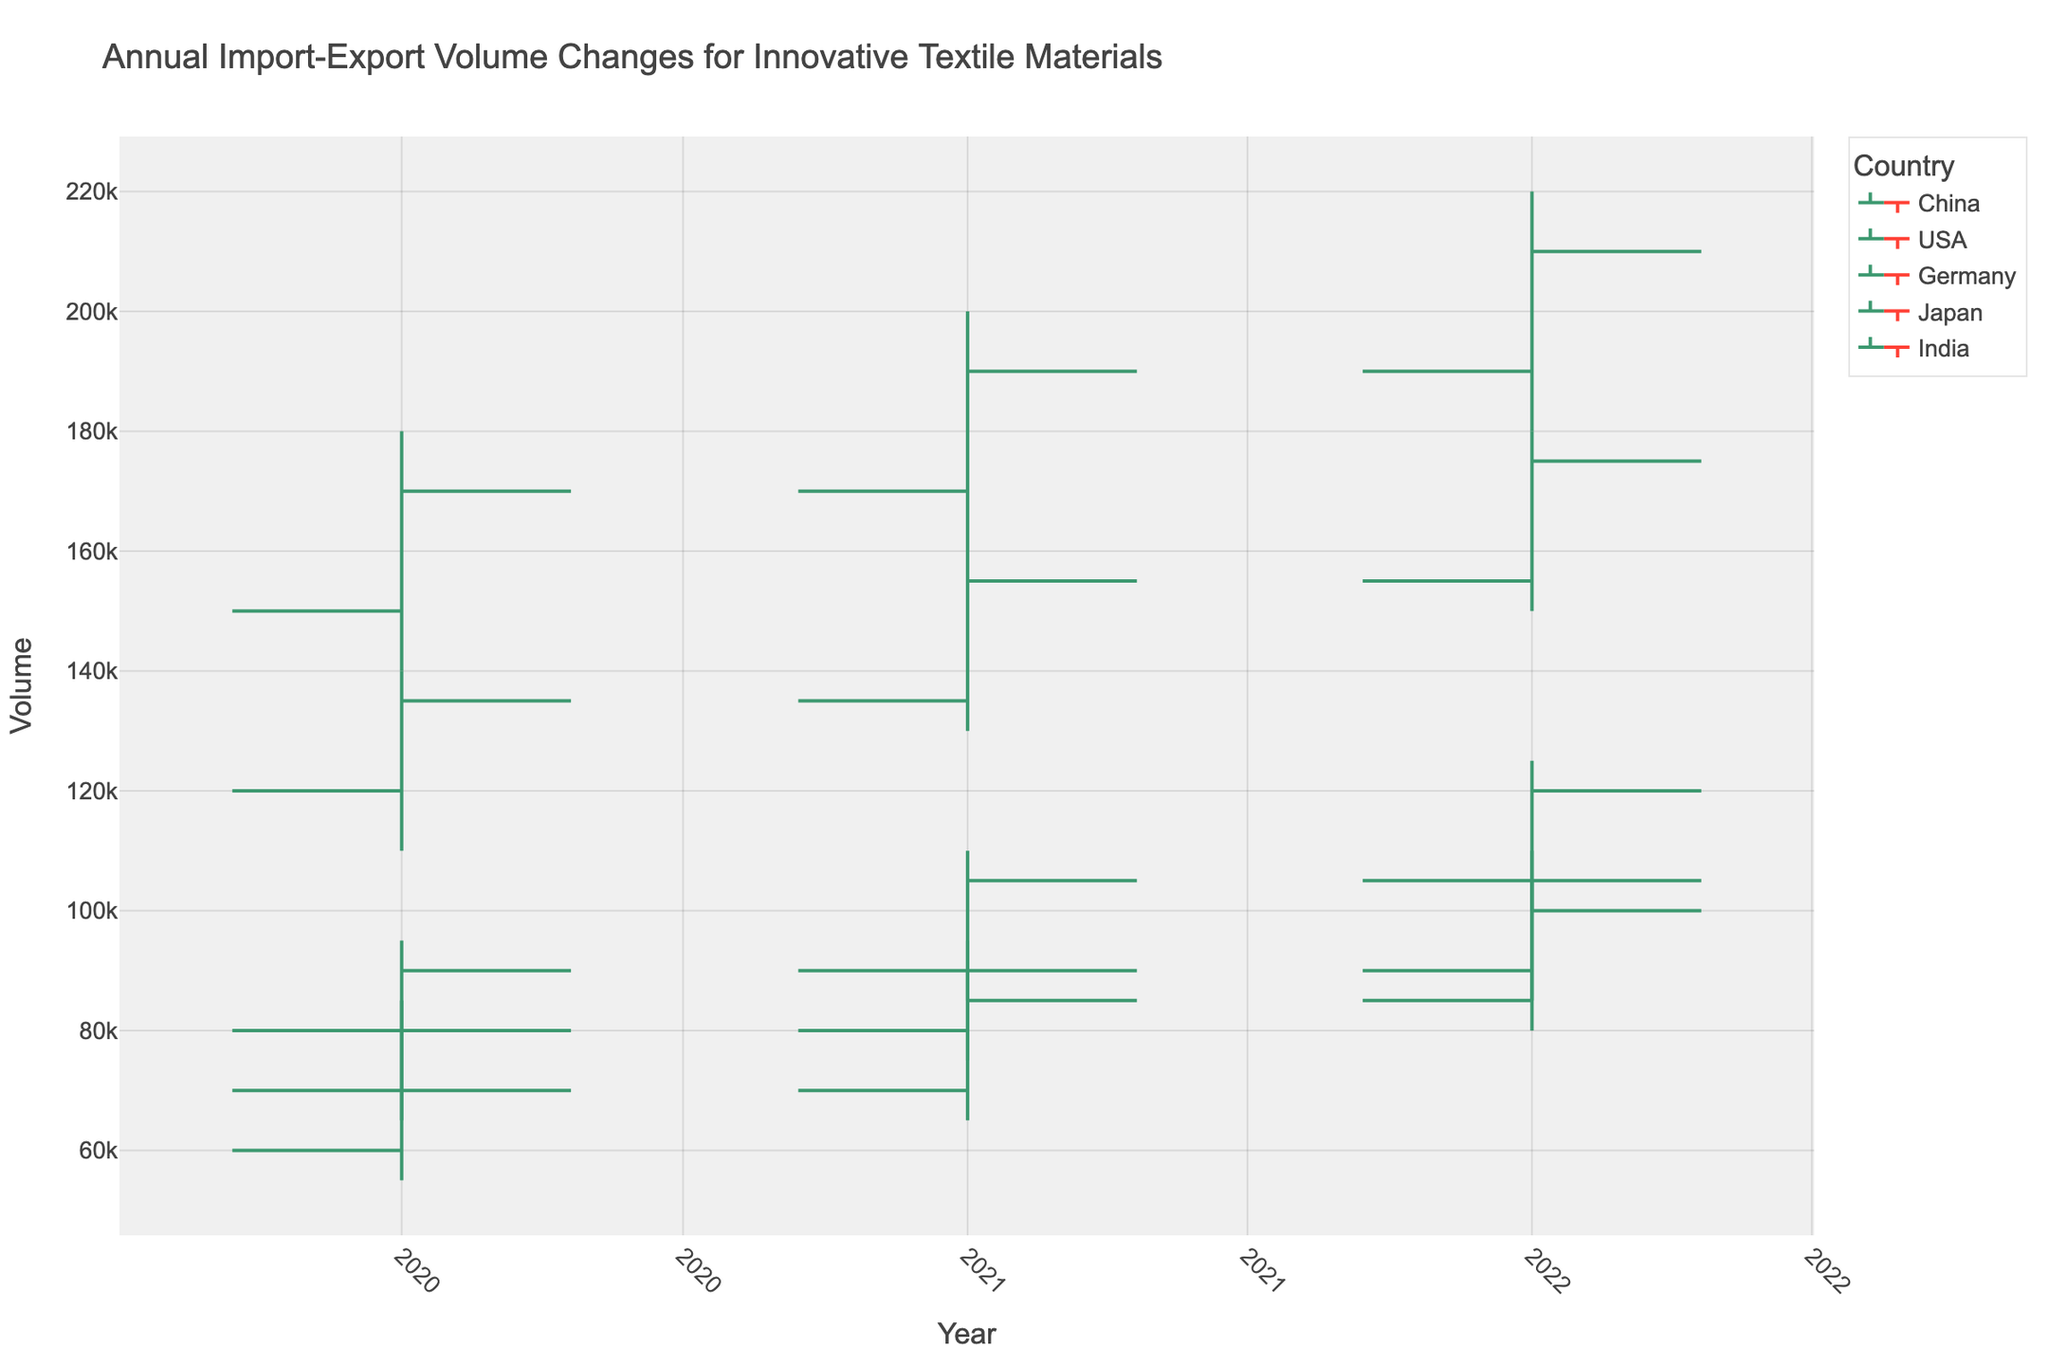Which country had the highest import-export volume in 2020? The highest import-export volume in 2020 is indicated by the highest "High" value in the OHLC chart. For 2020, China had the highest volume with a peak at 180,000.
Answer: China What was the lowest import-export volume for India in 2021? The lowest import-export volume for India in 2021 is represented by the "Low" value. According to the chart, the lowest value for India in 2021 was 65,000.
Answer: 65,000 How did the closing volume of USA change from 2020 to 2022? To determine this, look at the "Close" values for USA in 2020, 2021, and 2022. In 2020, it was 135,000; in 2021, 155,000; and in 2022, 175,000. So it increased each year.
Answer: Increased Which country had the smallest range of import-export volumes in 2022, and what was the range? The range can be calculated by subtracting the "Low" value from the "High" value for each country in 2022. Germany had the smallest range: 125,000 - 100,000 = 25,000.
Answer: Germany, 25,000 What is the average closing volume for Japan across all the years presented? The closing volumes for Japan are 80,000 (2020), 90,000 (2021), and 105,000 (2022). The average is (80,000 + 90,000 + 105,000) / 3.
Answer: 91,667 Compare the import-export trend for China and Germany from 2020 to 2022. Looking at the "Close" values for both countries, China's volumes went from 170,000 to 190,000 to 210,000, showing a consistent rise. Germany's volumes went from 90,000 to 105,000 to 120,000, also showing a rise but with lower values.
Answer: Both increased, China at higher volumes What was the highest recorded import-export volume overall between 2020 and 2022? The highest volume overall is indicated by the maximum "High" value in the data set. That value is 220,000 for China in 2022.
Answer: 220,000 Between USA and India, which country had a higher average “Low” value across the three years? Calculate the average "Low" values for USA (110,000, 130,000, 150,000) and India (55,000, 65,000, 80,000). For USA: (110,000 + 130,000 + 150,000) / 3 = 130,000. For India: (55,000 + 65,000 + 80,000) / 3 = 66,667. USA has a higher average.
Answer: USA What was the percentage increase in the closing volume for China from 2021 to 2022? Calculate the percentage increase using the "Close" values: ((210,000 - 190,000) / 190,000) * 100 = 10.53%.
Answer: 10.53% 